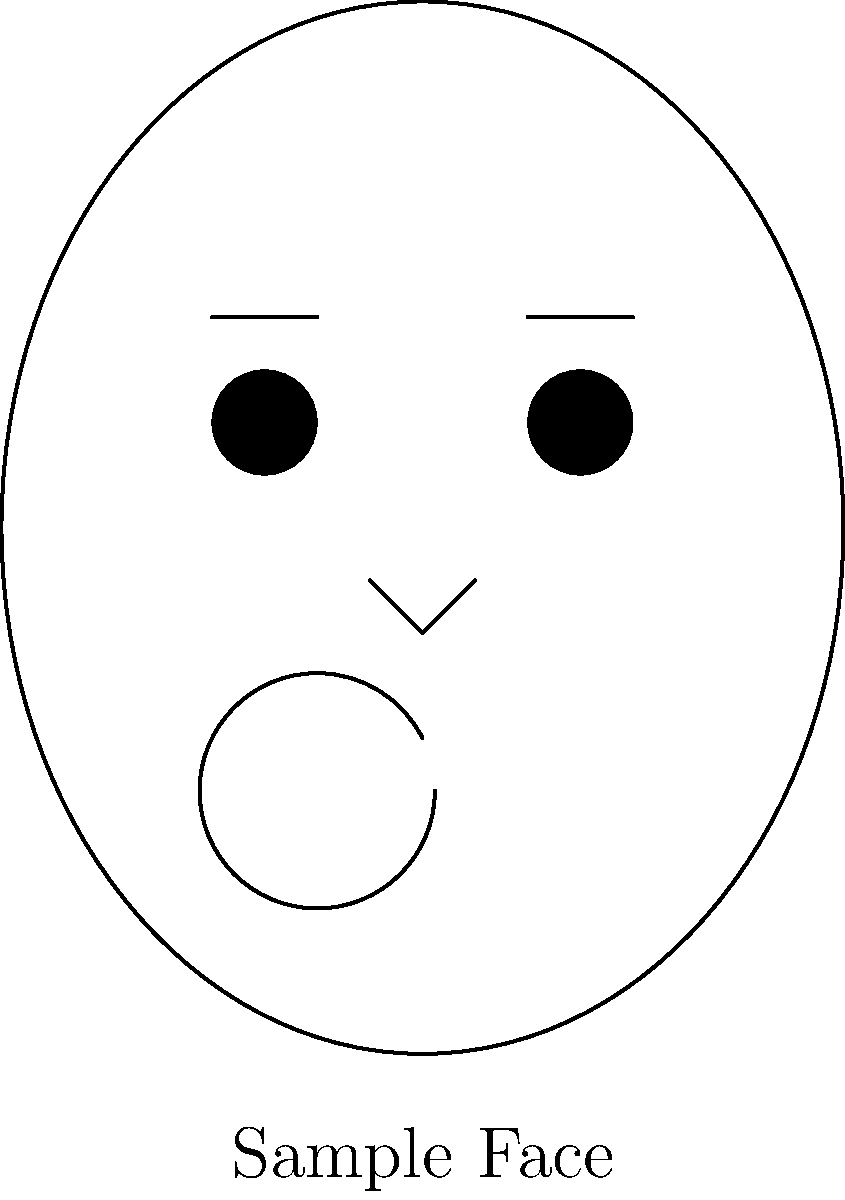In facial recognition systems, which of the following facial features is considered the most reliable and unique for identification purposes?

A) Eyes
B) Nose
C) Mouth
D) Eyebrows To answer this question, let's consider the characteristics of each facial feature:

1. Eyes:
   - Highly detailed and complex structures
   - Contain unique patterns in the iris
   - Relatively stable over time
   - Less affected by facial expressions

2. Nose:
   - Prominent feature, but less detailed
   - Shape can be affected by viewing angle
   - Generally stable, but can change with age or surgery

3. Mouth:
   - Highly variable due to facial expressions
   - Shape can change significantly
   - Less reliable for consistent identification

4. Eyebrows:
   - Can change shape due to grooming or aging
   - Less detailed than other features
   - More susceptible to occlusion (e.g., by hair or glasses)

Among these options, the eyes, specifically the iris patterns, are considered the most reliable and unique for identification purposes. This is because:

1. The iris contains complex and detailed patterns that are unique to each individual.
2. Iris patterns are stable throughout a person's life, unlike other features that may change with age or expression.
3. The iris is less affected by external factors like facial expressions or minor injuries.
4. Iris recognition systems have shown high accuracy rates in large-scale implementations.

While all facial features contribute to facial recognition, the uniqueness and stability of the iris make it the most reliable option among those listed for identification purposes in facial recognition systems.
Answer: A) Eyes 